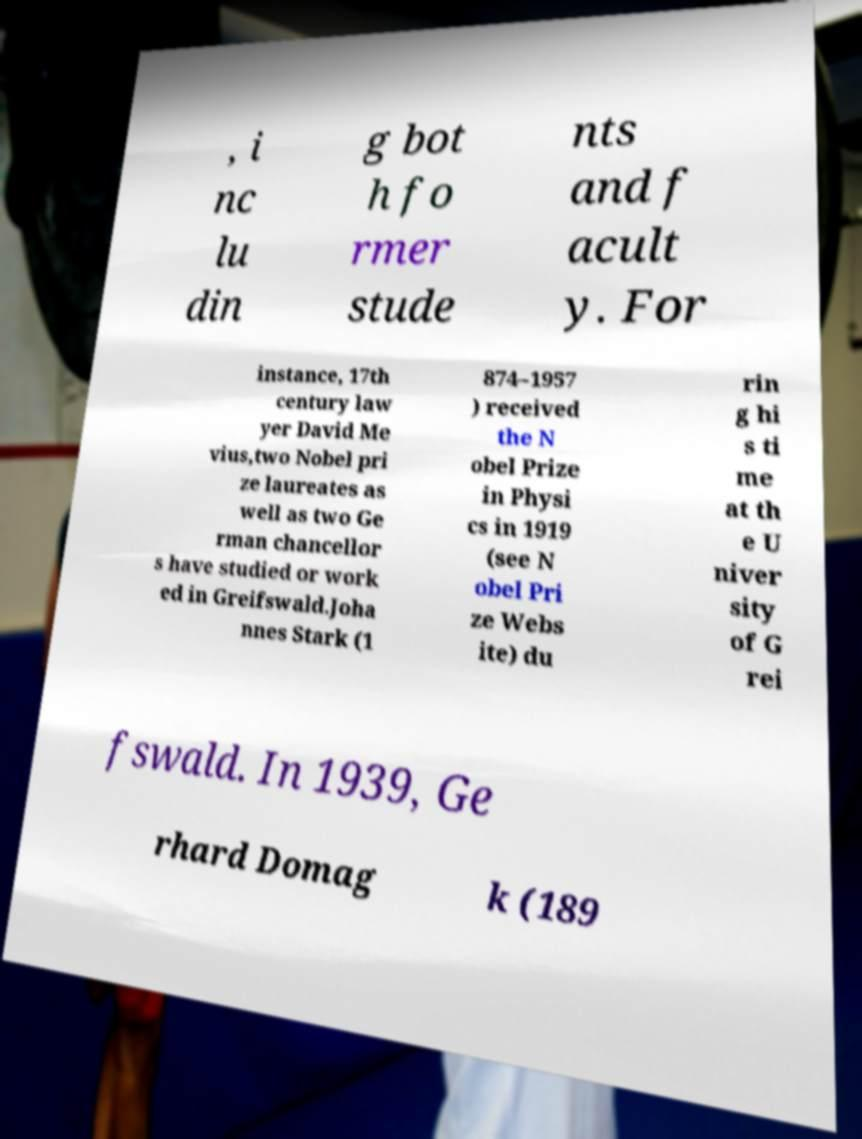For documentation purposes, I need the text within this image transcribed. Could you provide that? , i nc lu din g bot h fo rmer stude nts and f acult y. For instance, 17th century law yer David Me vius,two Nobel pri ze laureates as well as two Ge rman chancellor s have studied or work ed in Greifswald.Joha nnes Stark (1 874–1957 ) received the N obel Prize in Physi cs in 1919 (see N obel Pri ze Webs ite) du rin g hi s ti me at th e U niver sity of G rei fswald. In 1939, Ge rhard Domag k (189 